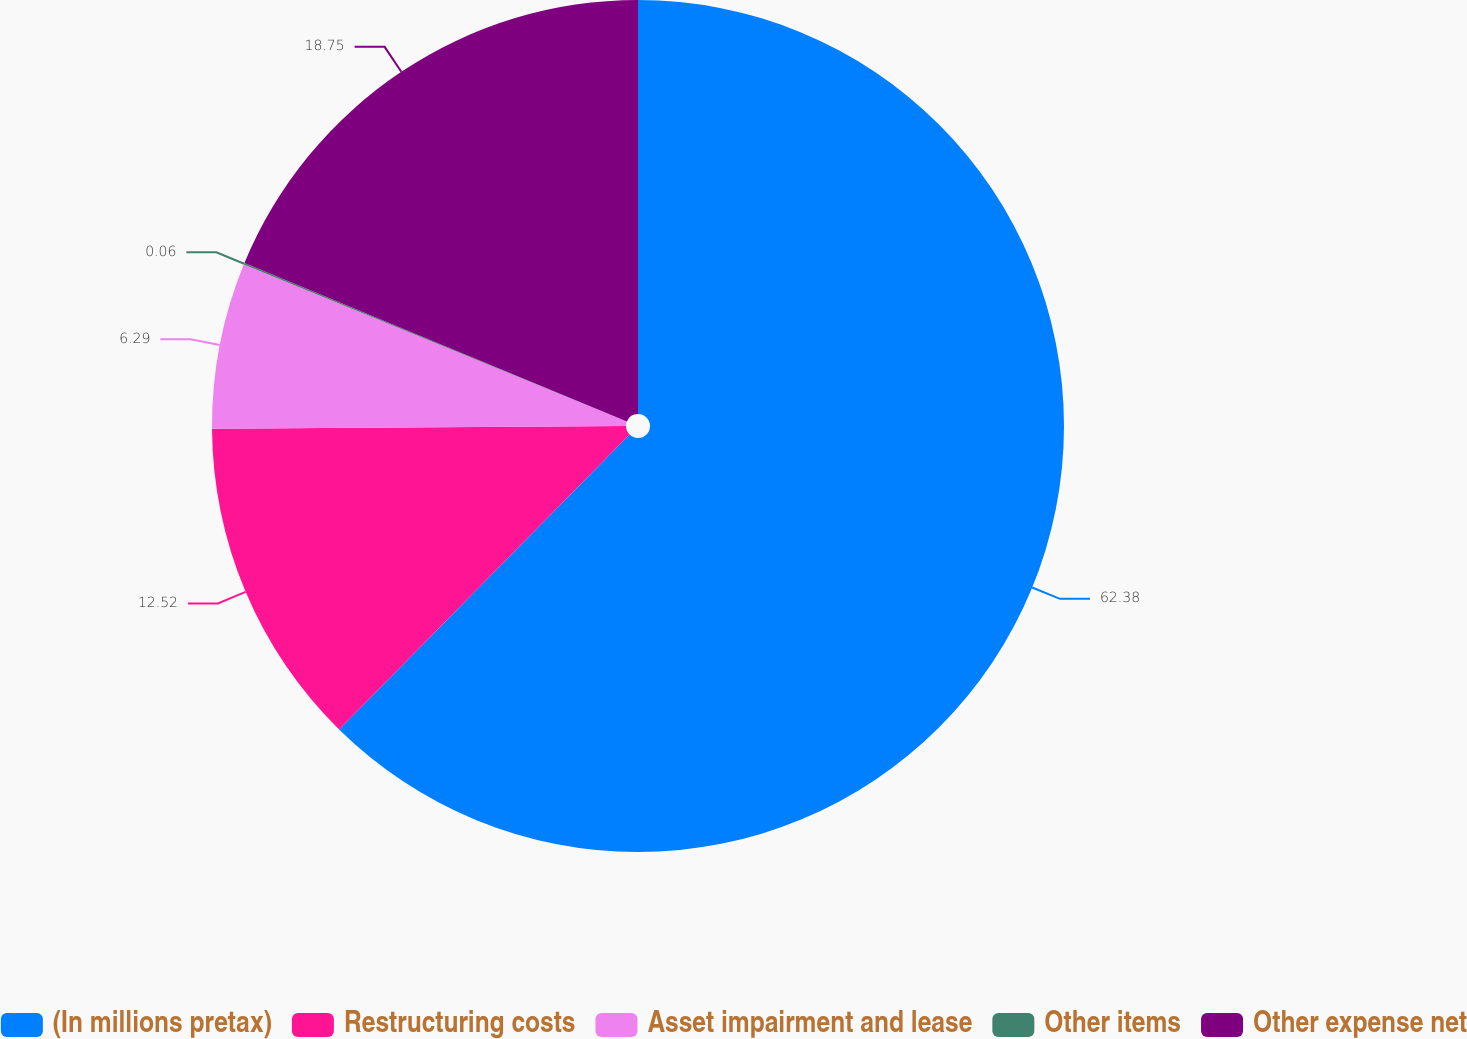<chart> <loc_0><loc_0><loc_500><loc_500><pie_chart><fcel>(In millions pretax)<fcel>Restructuring costs<fcel>Asset impairment and lease<fcel>Other items<fcel>Other expense net<nl><fcel>62.37%<fcel>12.52%<fcel>6.29%<fcel>0.06%<fcel>18.75%<nl></chart> 